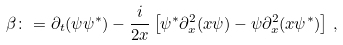Convert formula to latex. <formula><loc_0><loc_0><loc_500><loc_500>\beta \colon = \partial _ { t } ( \psi \psi ^ { \ast } ) - \frac { i } { 2 x } \left [ \psi ^ { \ast } \partial ^ { 2 } _ { x } ( x \psi ) - \psi \partial ^ { 2 } _ { x } ( x \psi ^ { \ast } ) \right ] \, ,</formula> 